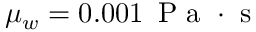<formula> <loc_0><loc_0><loc_500><loc_500>\mu _ { w } = 0 . 0 0 1 \, P a \cdot s</formula> 